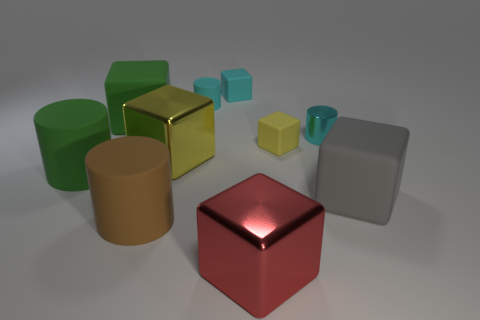Describe the textures of the objects seen here. In the image, a variety of textures are present. The green, yellow, and red blocks have a smooth, reflective metal finish, while the blue and smaller yellow blocks appear as matte rubber. The grey and cylindrical gold objects have a less reflective metallic texture. 